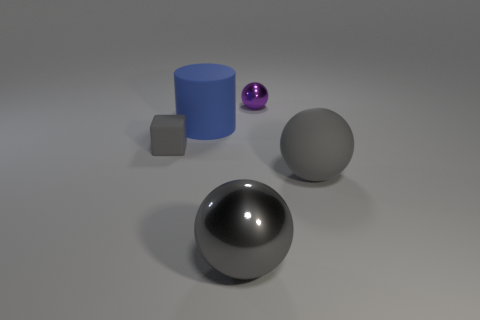Add 4 red matte objects. How many objects exist? 9 Subtract all balls. How many objects are left? 2 Subtract all gray spheres. How many spheres are left? 1 Subtract all purple spheres. How many spheres are left? 2 Subtract all large spheres. Subtract all small purple spheres. How many objects are left? 2 Add 2 tiny things. How many tiny things are left? 4 Add 3 big spheres. How many big spheres exist? 5 Subtract 0 cyan balls. How many objects are left? 5 Subtract 1 blocks. How many blocks are left? 0 Subtract all cyan spheres. Subtract all blue cylinders. How many spheres are left? 3 